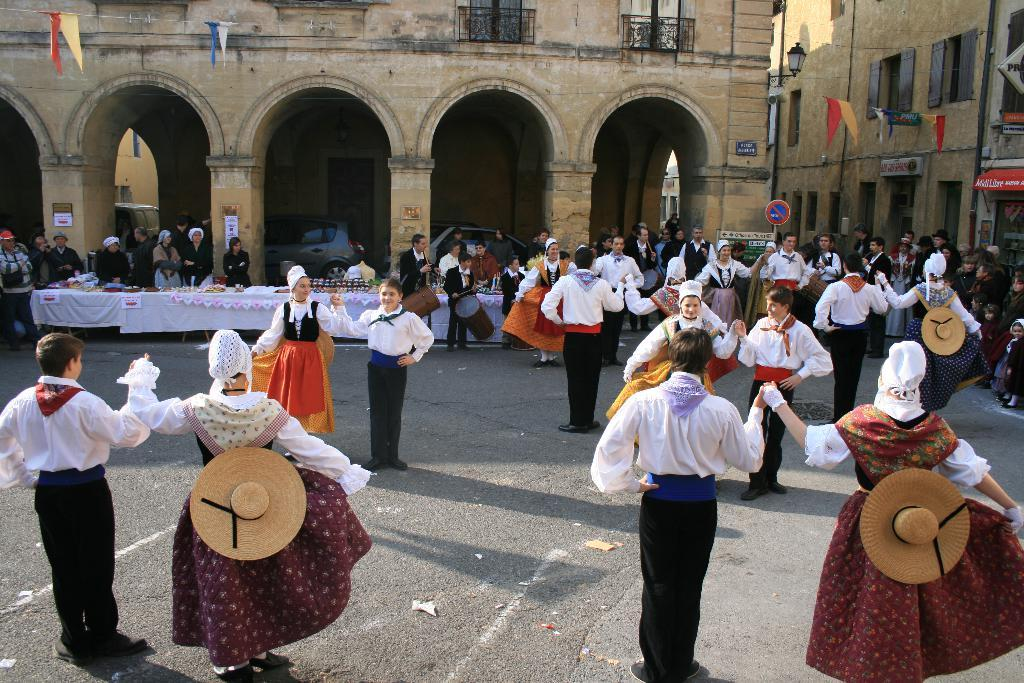What are the people in the image doing? The people in the image are dancing. What are the people wearing while dancing? The people are wearing costumes. Where are the dancing people located in the image? The dancing people are at the bottom of the image. What can be seen in the background of the image? There is a sign board, tables, people, buildings, and cars in the background of the image. What type of toothbrush can be seen in the hands of the people dancing in the image? There is no toothbrush present in the image; the people are dancing while wearing costumes. What material is the brass used for the tables in the background of the image? There is no mention of brass or tables made of brass in the image; the tables in the background are not described in detail. 